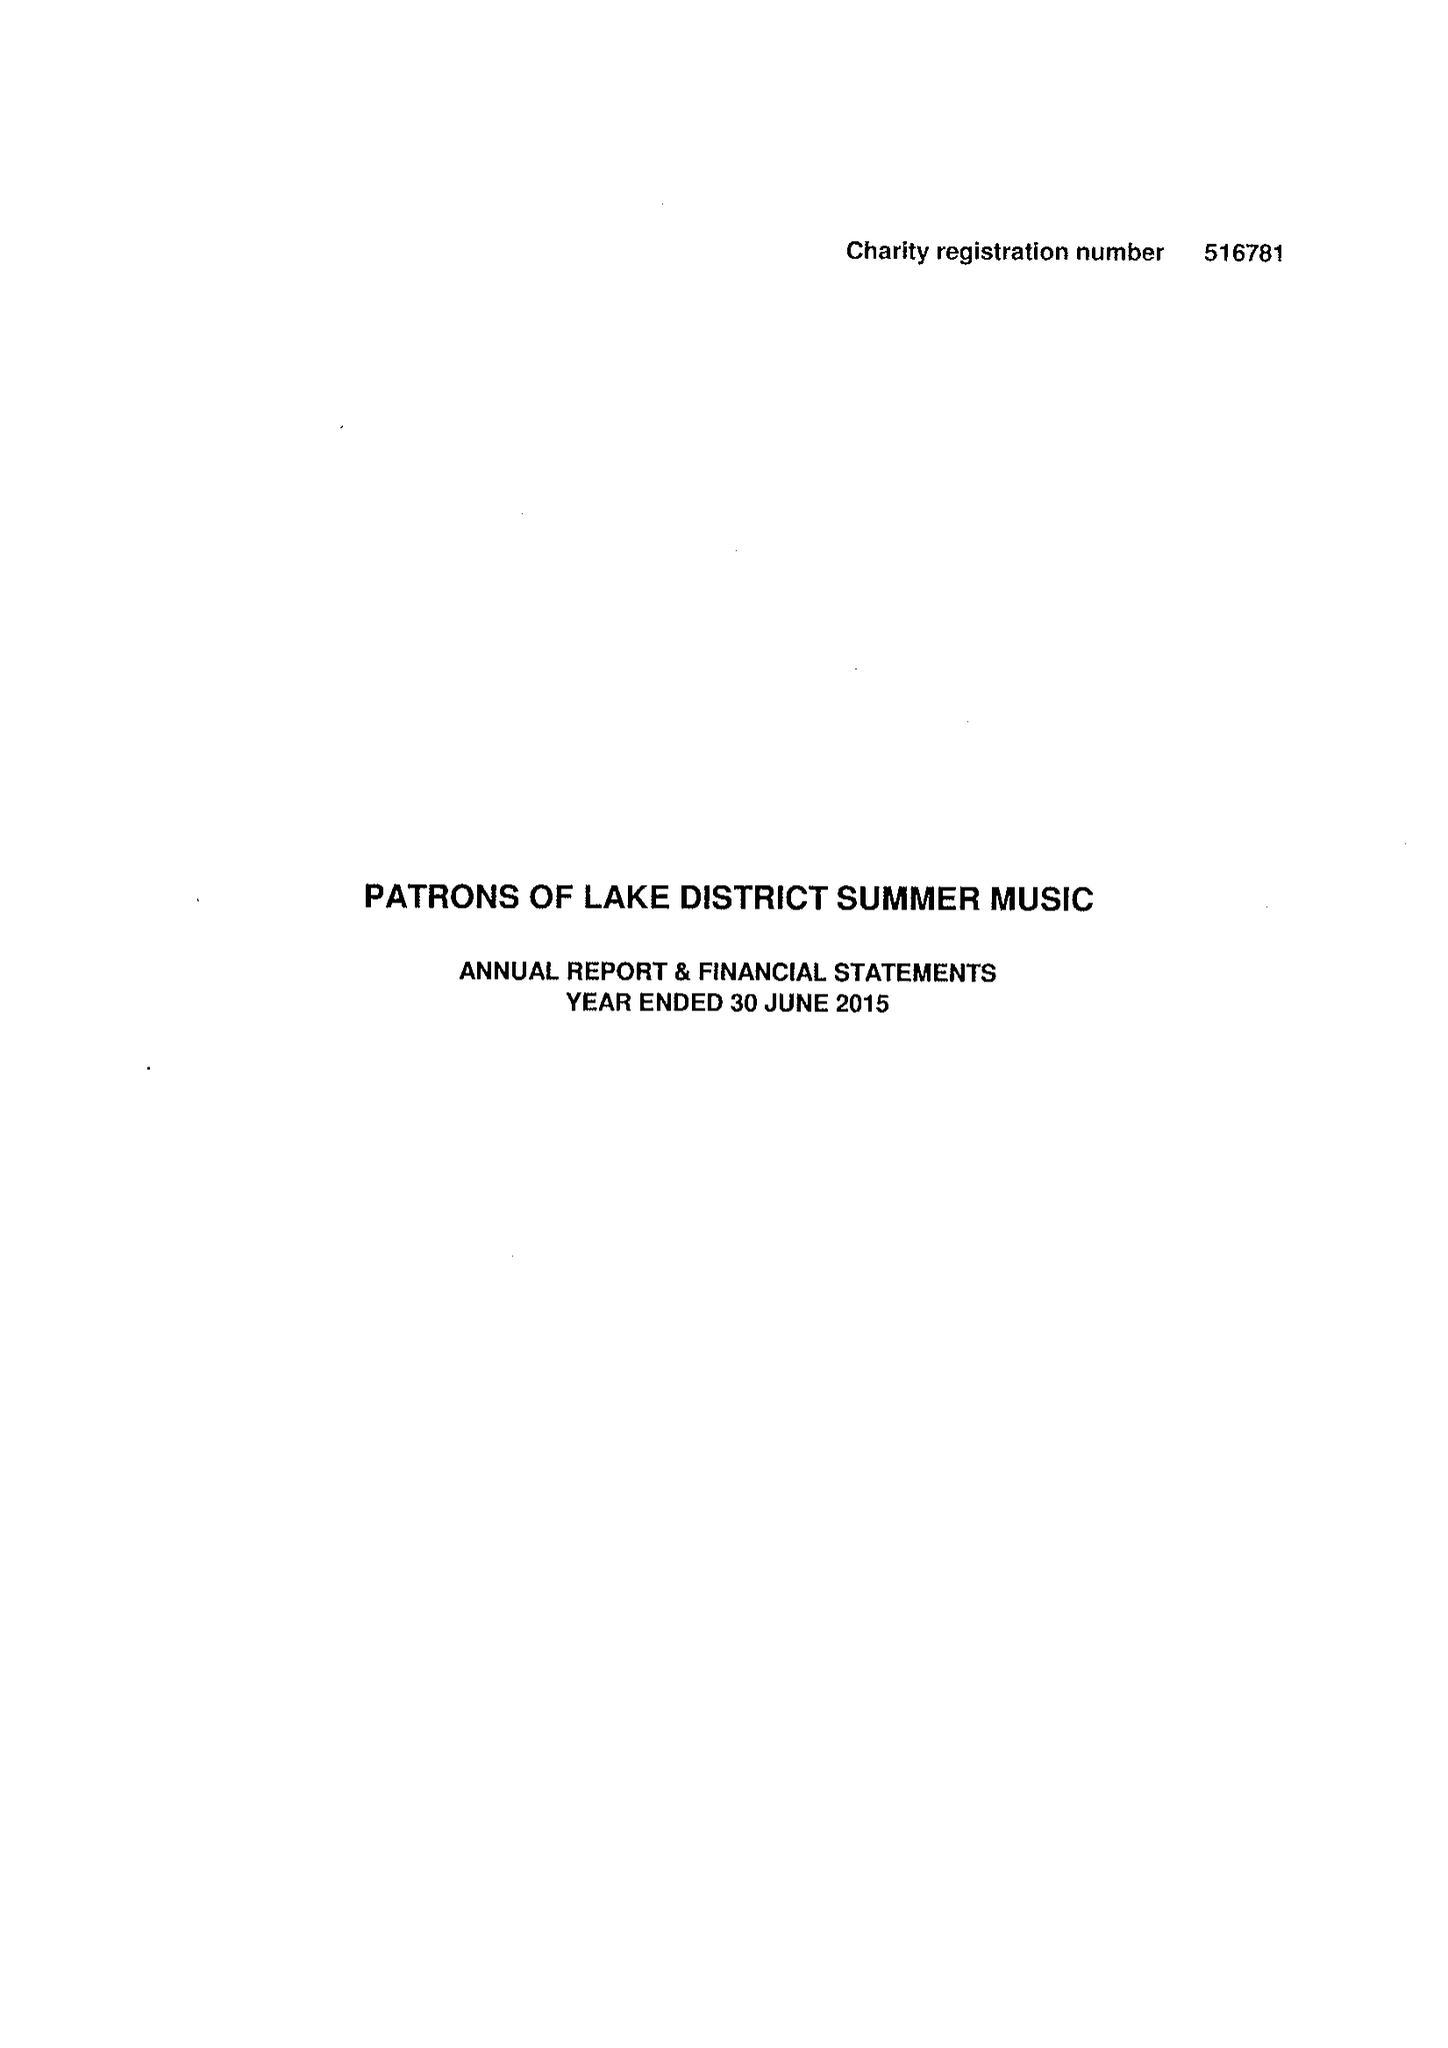What is the value for the address__street_line?
Answer the question using a single word or phrase. 14 ESTHWAITE AVENUE 